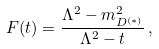<formula> <loc_0><loc_0><loc_500><loc_500>F ( t ) = \frac { \Lambda ^ { 2 } - m _ { D ^ { ( \ast ) } } ^ { 2 } } { \Lambda ^ { 2 } - t } \, ,</formula> 